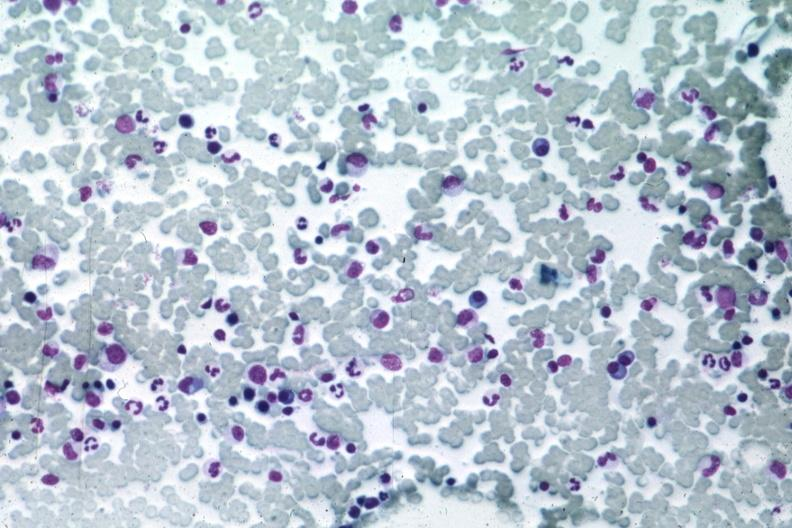s hematologic present?
Answer the question using a single word or phrase. Yes 